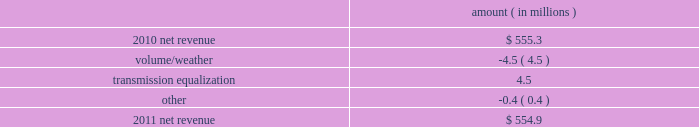Entergy mississippi , inc .
Management 2019s financial discussion and analysis plan to spin off the utility 2019s transmission business see the 201cplan to spin off the utility 2019s transmission business 201d section of entergy corporation and subsidiaries management 2019s financial discussion and analysis for a discussion of this matter , including the planned retirement of debt and preferred securities .
Results of operations net income 2011 compared to 2010 net income increased $ 23.4 million primarily due to a lower effective income tax rate .
2010 compared to 2009 net income increased $ 6.0 million primarily due to higher net revenue and higher other income , partially offset by higher taxes other than income taxes , higher depreciation and amortization expenses , and higher interest expense .
Net revenue 2011 compared to 2010 net revenue consists of operating revenues net of : 1 ) fuel , fuel-related expenses , and gas purchased for resale , 2 ) purchased power expenses , and 3 ) other regulatory charges ( credits ) .
Following is an analysis of the change in net revenue comparing 2011 to 2010 .
Amount ( in millions ) .
The volume/weather variance is primarily due to a decrease of 97 gwh in weather-adjusted usage in the residential and commercial sectors and a decrease in sales volume in the unbilled sales period .
The transmission equalization variance is primarily due to the addition in 2011 of transmission investments that are subject to equalization .
Gross operating revenues and fuel and purchased power expenses gross operating revenues increased primarily due to an increase of $ 57.5 million in gross wholesale revenues due to an increase in sales to affiliated customers , partially offset by a decrease of $ 26.9 million in power management rider revenue .
Fuel and purchased power expenses increased primarily due to an increase in deferred fuel expense as a result of higher fuel revenues due to higher fuel rates , partially offset by a decrease in the average market prices of natural gas and purchased power. .
Based on the review of the net revenue changes what was ratio of the volume/weather to the transmission equalization? 
Computations: (-4.5 / 4.5)
Answer: -1.0. 